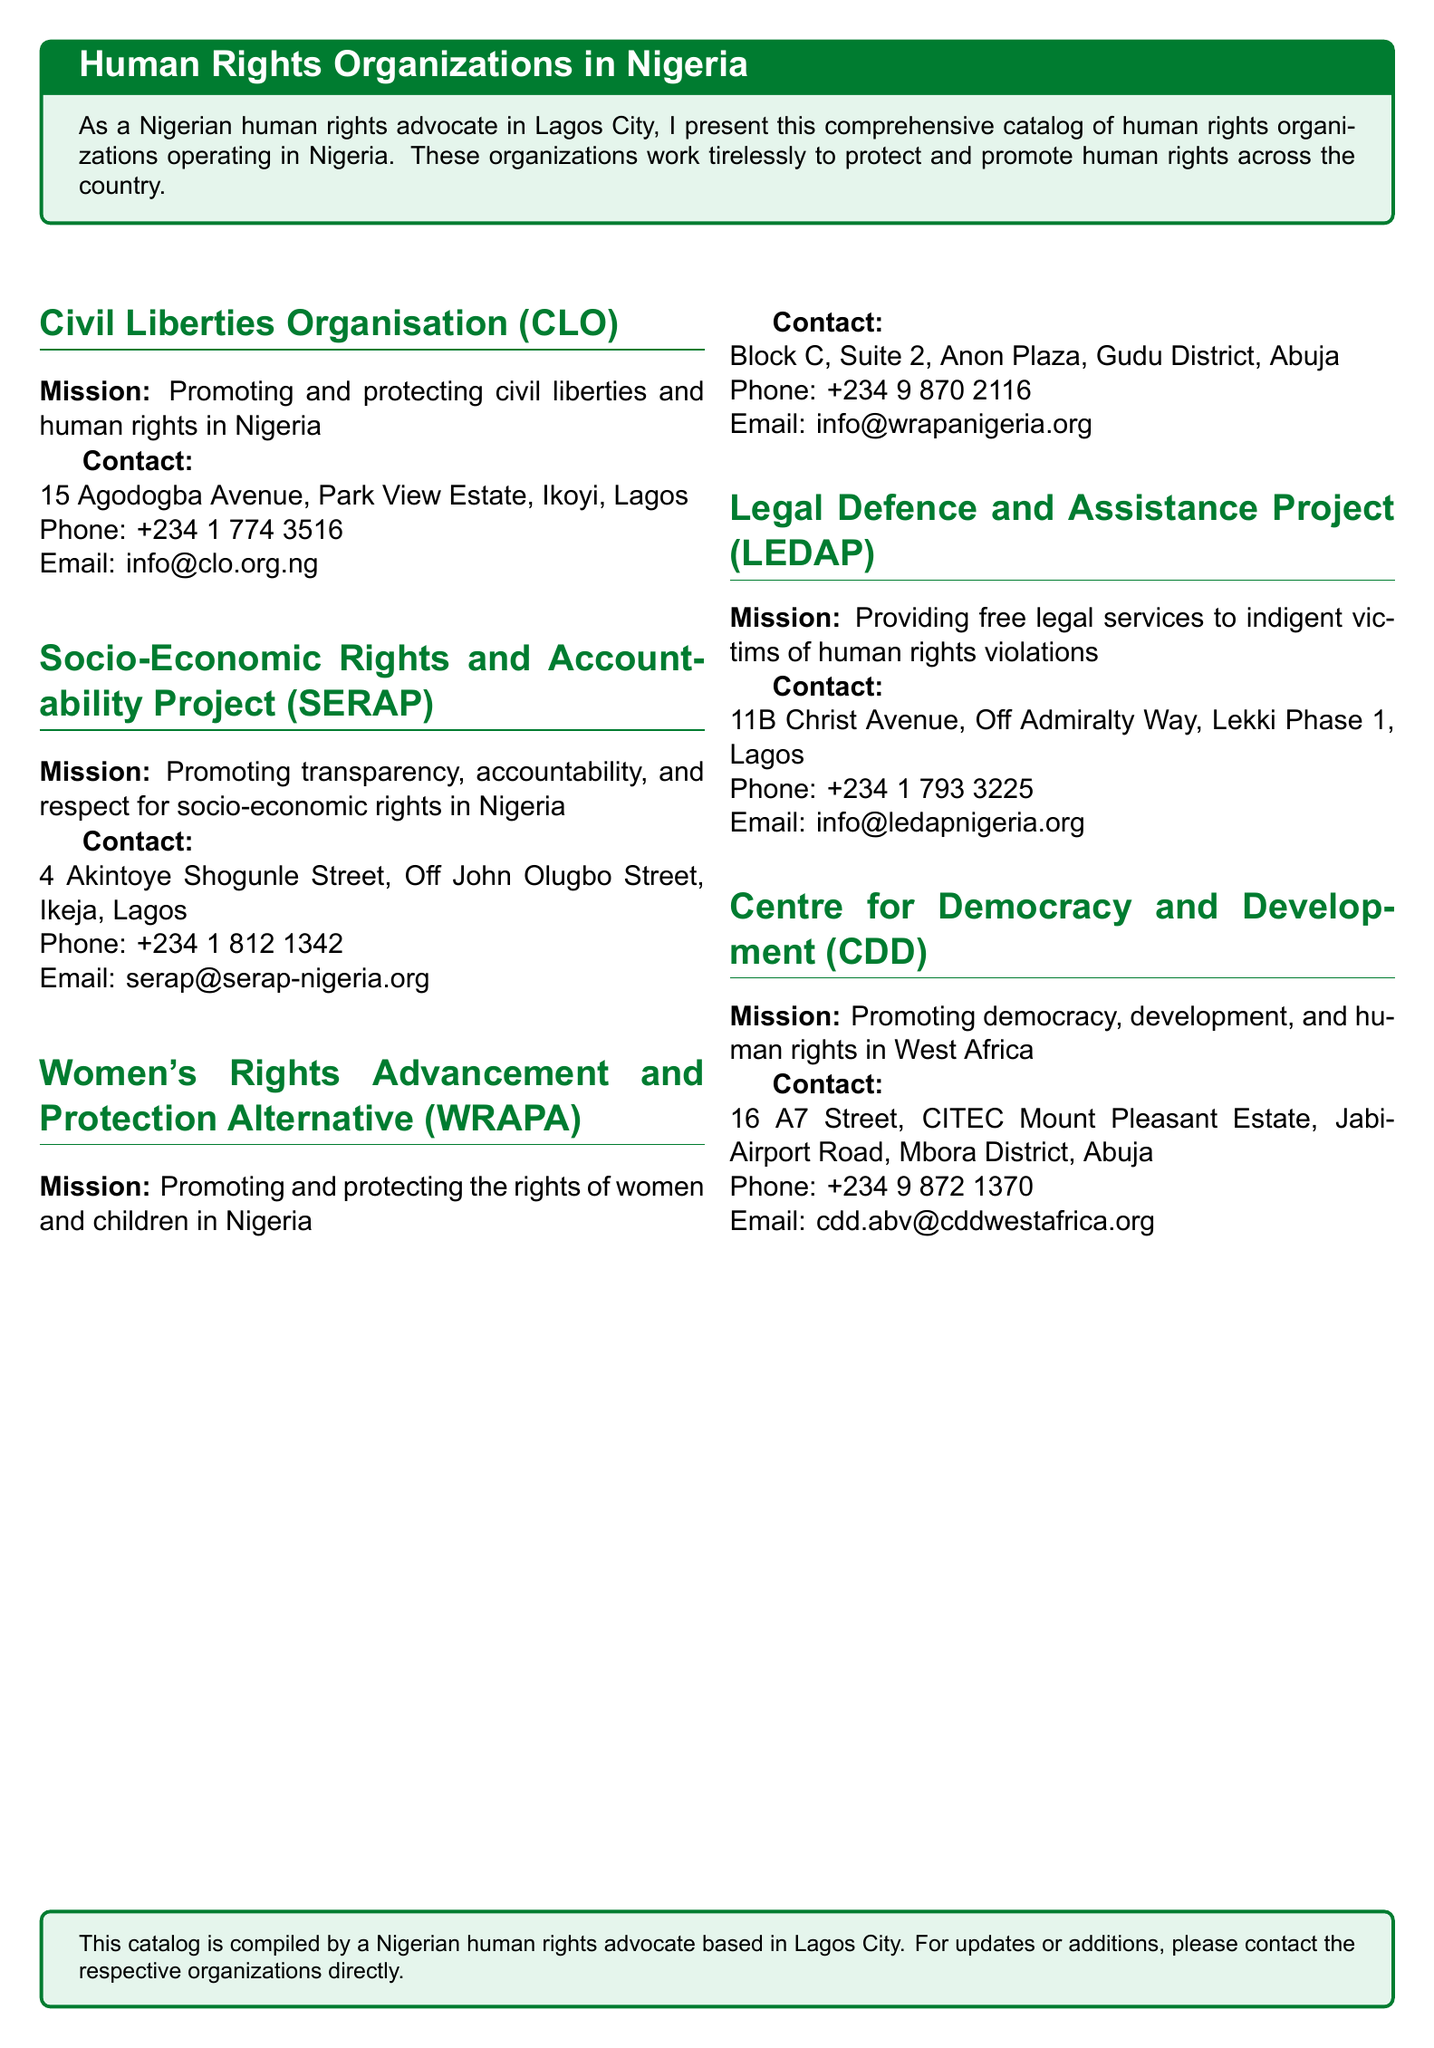What is the mission of the Civil Liberties Organisation? The mission is stated clearly under their section.
Answer: Promoting and protecting civil liberties and human rights in Nigeria What is the contact phone number for SERAP? The phone number is provided in the contact section for SERAP.
Answer: +234 1 812 1342 Where is WRAPA located? The contact section provides the address for WRAPA.
Answer: Block C, Suite 2, Anon Plaza, Gudu District, Abuja How many organizations are listed in the document? Count the number of organizations presented in the document.
Answer: Five What is the primary focus area of LEDAP? The mission statement describes the focus area of LEDAP.
Answer: Providing free legal services to indigent victims of human rights violations Which organization operates in both Lagos and Abuja? Analyze the locations of the organizations to determine which operates in both cities.
Answer: Women's Rights Advancement and Protection Alternative (WRAPA) What is the email address for the Centre for Democracy and Development? The email is listed in the contact information for the CDD.
Answer: cdd.abv@cddwestafrica.org 